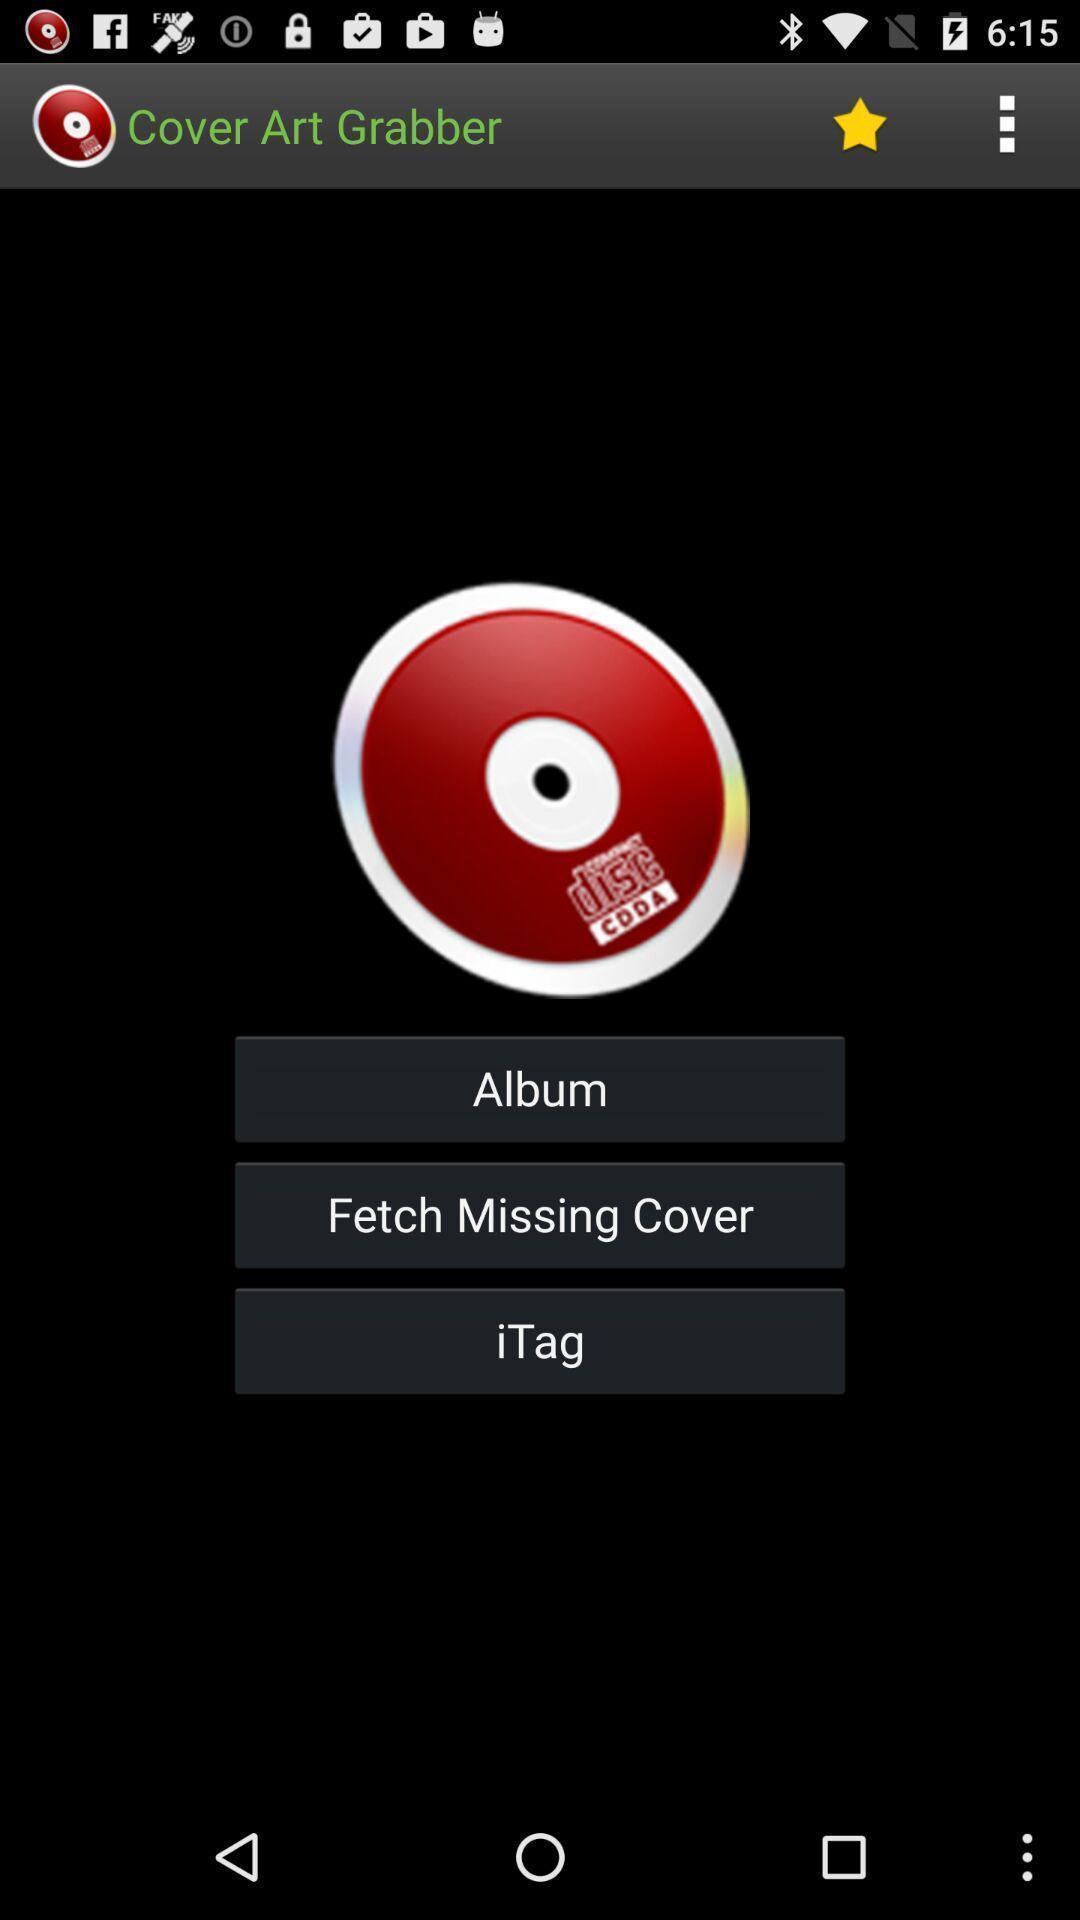Tell me about the visual elements in this screen capture. Screen showing various options of a photo editing app. 